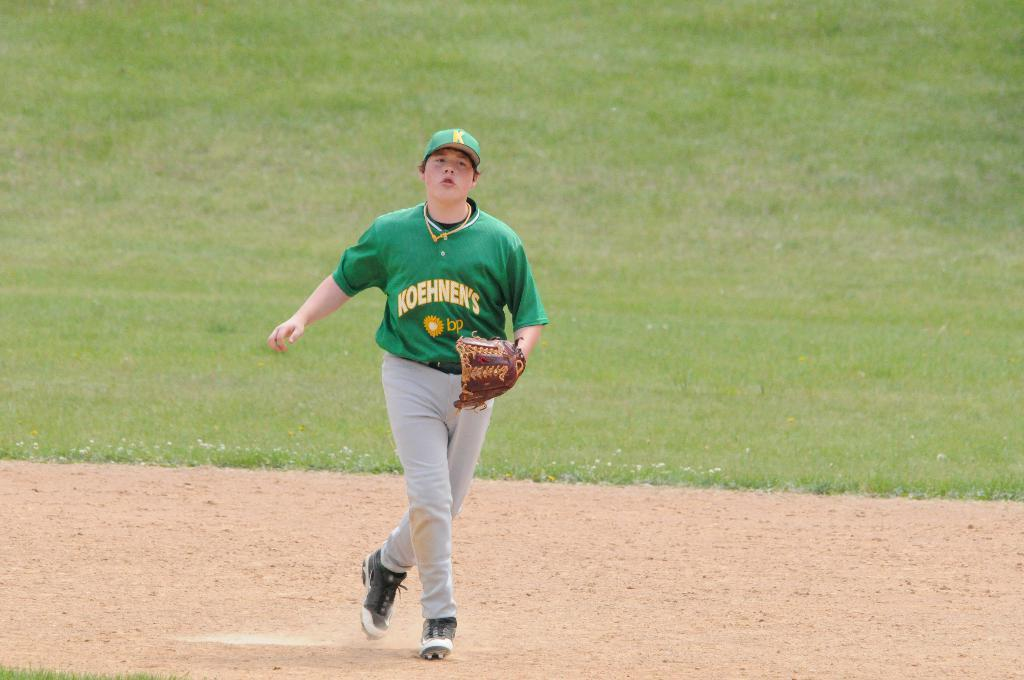Provide a one-sentence caption for the provided image. player in green for koehnen's bp looking up for the ball. 